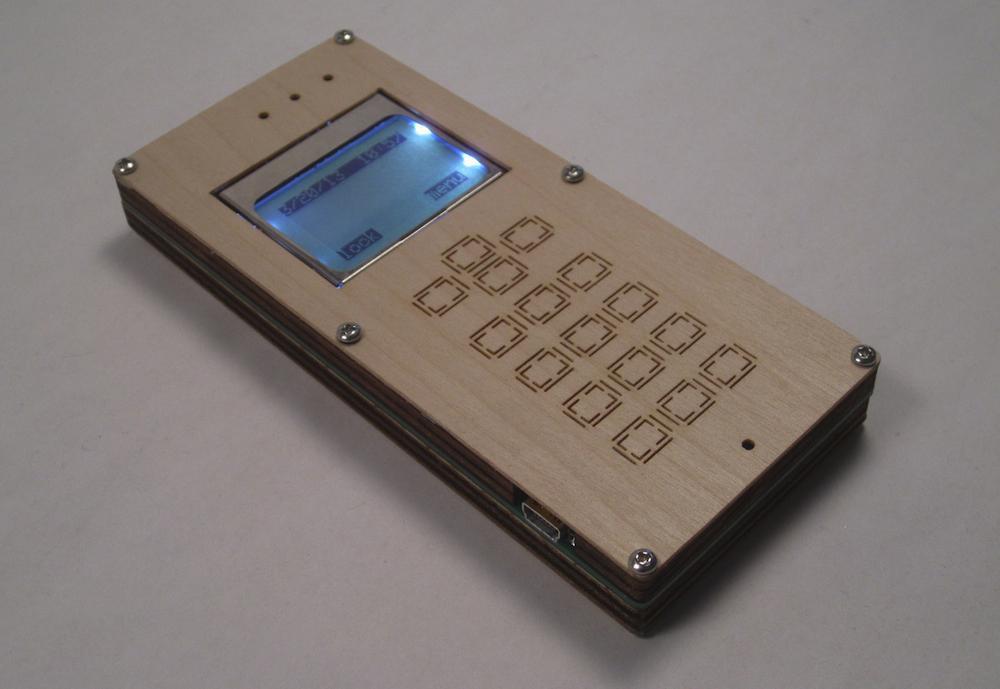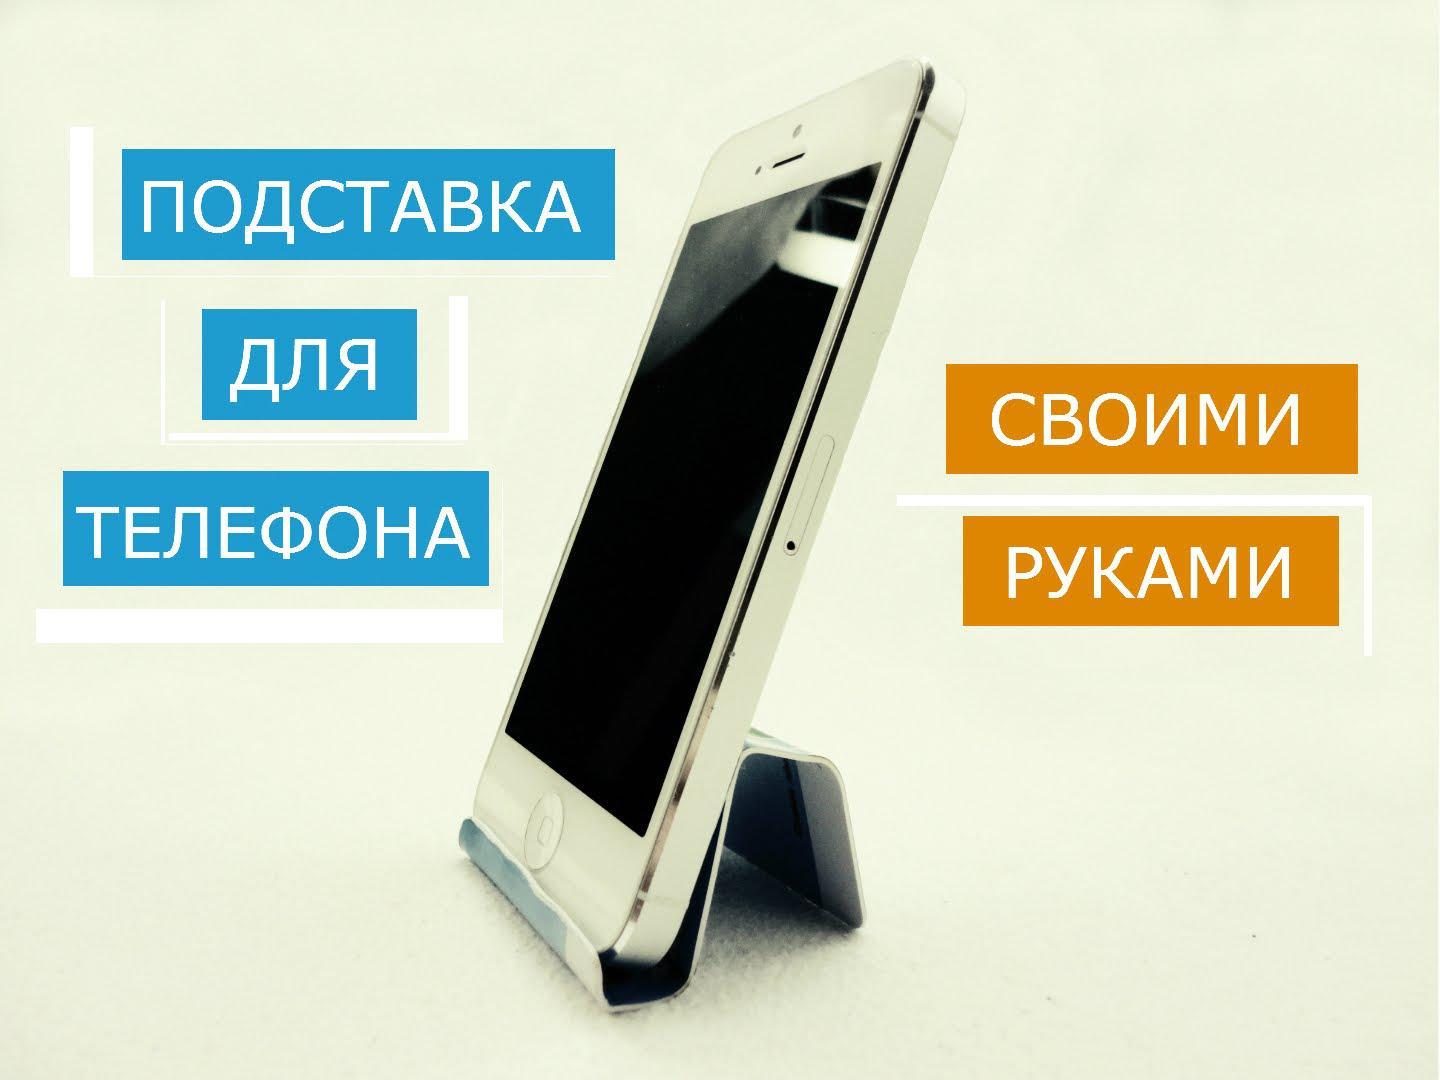The first image is the image on the left, the second image is the image on the right. Considering the images on both sides, is "At least one cell phone is on a stand facing left." valid? Answer yes or no. Yes. 